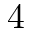Convert formula to latex. <formula><loc_0><loc_0><loc_500><loc_500>4</formula> 